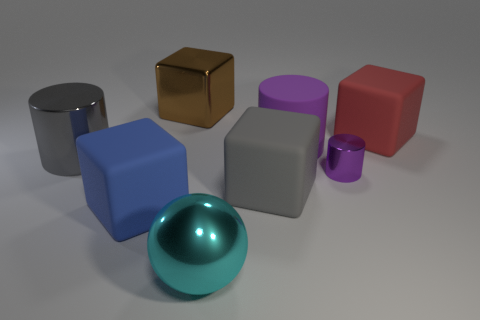There is a large gray object behind the purple metal cylinder; are there any brown metal things behind it? While there is a variety of colored objects in the image, there isn't a brown metal object located directly behind the large gray block. However, there is a brown metallic cube to the left front area of the arrangement. 